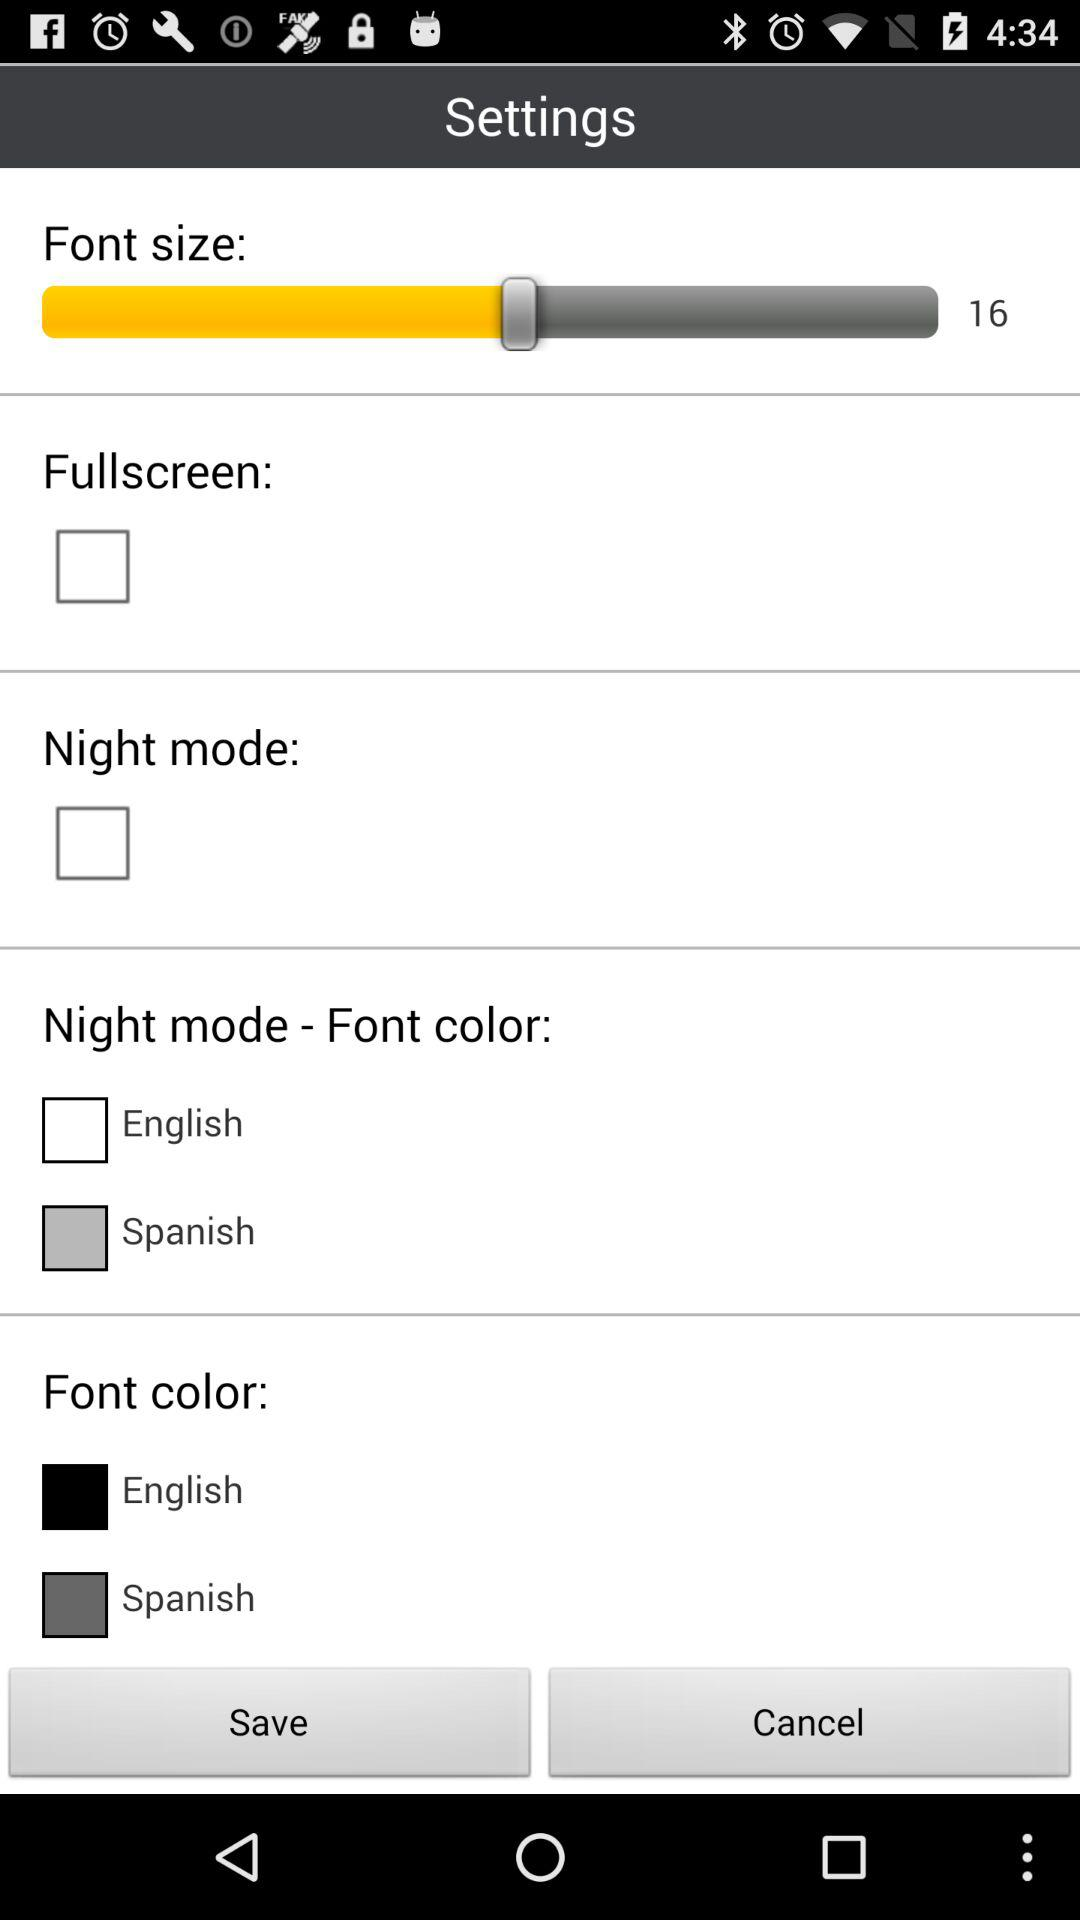What is selected night mode- font color?
When the provided information is insufficient, respond with <no answer>. <no answer> 